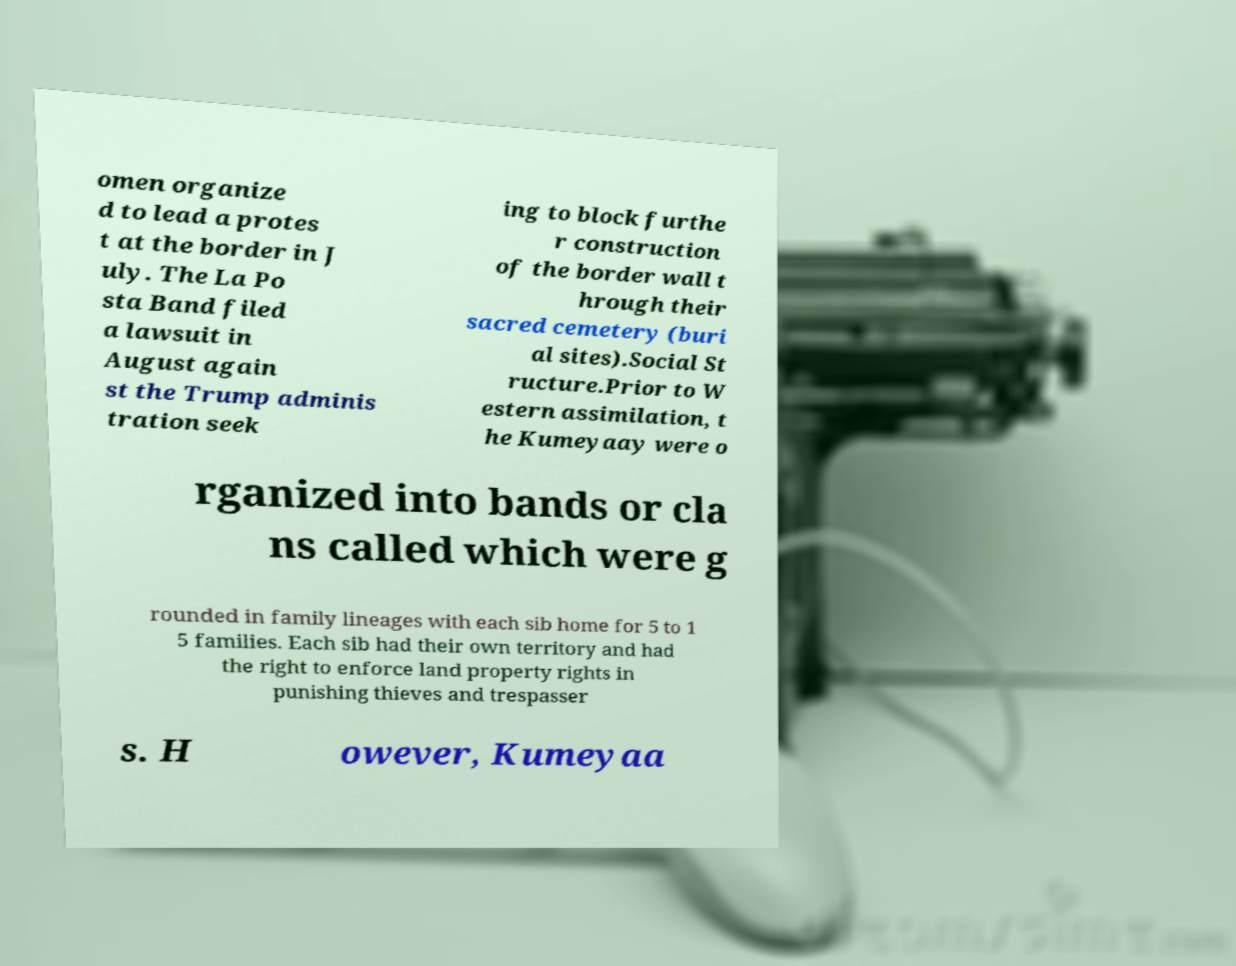What messages or text are displayed in this image? I need them in a readable, typed format. omen organize d to lead a protes t at the border in J uly. The La Po sta Band filed a lawsuit in August again st the Trump adminis tration seek ing to block furthe r construction of the border wall t hrough their sacred cemetery (buri al sites).Social St ructure.Prior to W estern assimilation, t he Kumeyaay were o rganized into bands or cla ns called which were g rounded in family lineages with each sib home for 5 to 1 5 families. Each sib had their own territory and had the right to enforce land property rights in punishing thieves and trespasser s. H owever, Kumeyaa 